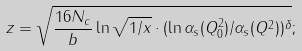Convert formula to latex. <formula><loc_0><loc_0><loc_500><loc_500>z = \sqrt { \frac { 1 6 N _ { c } } { b } \ln \sqrt { 1 / x } \cdot ( \ln \alpha _ { s } ( Q ^ { 2 } _ { 0 } ) / \alpha _ { s } ( Q ^ { 2 } ) ) ^ { \delta } } ;</formula> 